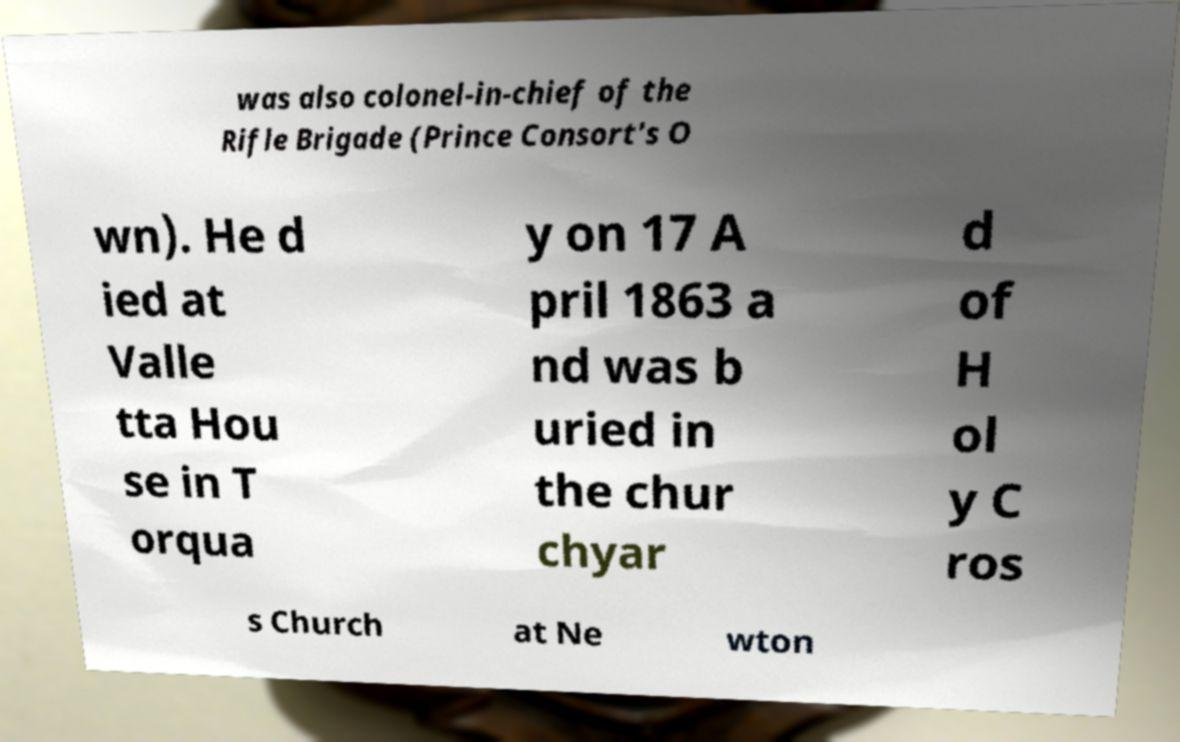There's text embedded in this image that I need extracted. Can you transcribe it verbatim? was also colonel-in-chief of the Rifle Brigade (Prince Consort's O wn). He d ied at Valle tta Hou se in T orqua y on 17 A pril 1863 a nd was b uried in the chur chyar d of H ol y C ros s Church at Ne wton 